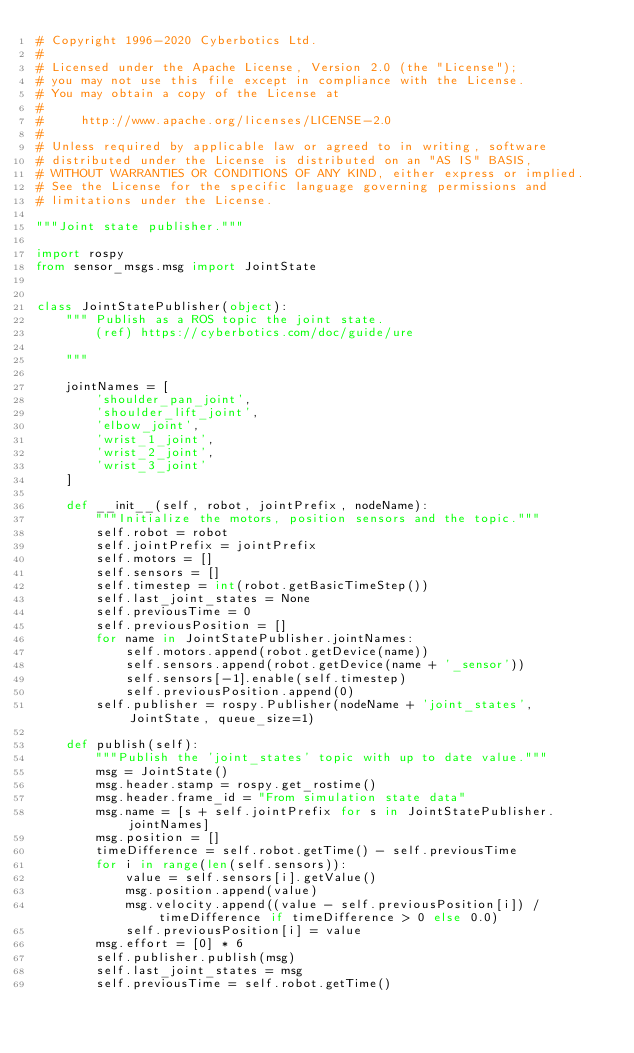<code> <loc_0><loc_0><loc_500><loc_500><_Python_># Copyright 1996-2020 Cyberbotics Ltd.
#
# Licensed under the Apache License, Version 2.0 (the "License");
# you may not use this file except in compliance with the License.
# You may obtain a copy of the License at
#
#     http://www.apache.org/licenses/LICENSE-2.0
#
# Unless required by applicable law or agreed to in writing, software
# distributed under the License is distributed on an "AS IS" BASIS,
# WITHOUT WARRANTIES OR CONDITIONS OF ANY KIND, either express or implied.
# See the License for the specific language governing permissions and
# limitations under the License.

"""Joint state publisher."""

import rospy
from sensor_msgs.msg import JointState


class JointStatePublisher(object):
    """ Publish as a ROS topic the joint state.
        (ref) https://cyberbotics.com/doc/guide/ure
    
    """

    jointNames = [
        'shoulder_pan_joint',
        'shoulder_lift_joint',
        'elbow_joint',
        'wrist_1_joint',
        'wrist_2_joint',
        'wrist_3_joint'
    ]

    def __init__(self, robot, jointPrefix, nodeName):
        """Initialize the motors, position sensors and the topic."""
        self.robot = robot
        self.jointPrefix = jointPrefix
        self.motors = []
        self.sensors = []
        self.timestep = int(robot.getBasicTimeStep())
        self.last_joint_states = None
        self.previousTime = 0
        self.previousPosition = []
        for name in JointStatePublisher.jointNames:
            self.motors.append(robot.getDevice(name))
            self.sensors.append(robot.getDevice(name + '_sensor'))
            self.sensors[-1].enable(self.timestep)
            self.previousPosition.append(0)
        self.publisher = rospy.Publisher(nodeName + 'joint_states', JointState, queue_size=1)

    def publish(self):
        """Publish the 'joint_states' topic with up to date value."""
        msg = JointState()
        msg.header.stamp = rospy.get_rostime()
        msg.header.frame_id = "From simulation state data"
        msg.name = [s + self.jointPrefix for s in JointStatePublisher.jointNames]
        msg.position = []
        timeDifference = self.robot.getTime() - self.previousTime
        for i in range(len(self.sensors)):
            value = self.sensors[i].getValue()
            msg.position.append(value)
            msg.velocity.append((value - self.previousPosition[i]) / timeDifference if timeDifference > 0 else 0.0)
            self.previousPosition[i] = value
        msg.effort = [0] * 6
        self.publisher.publish(msg)
        self.last_joint_states = msg
        self.previousTime = self.robot.getTime()
</code> 